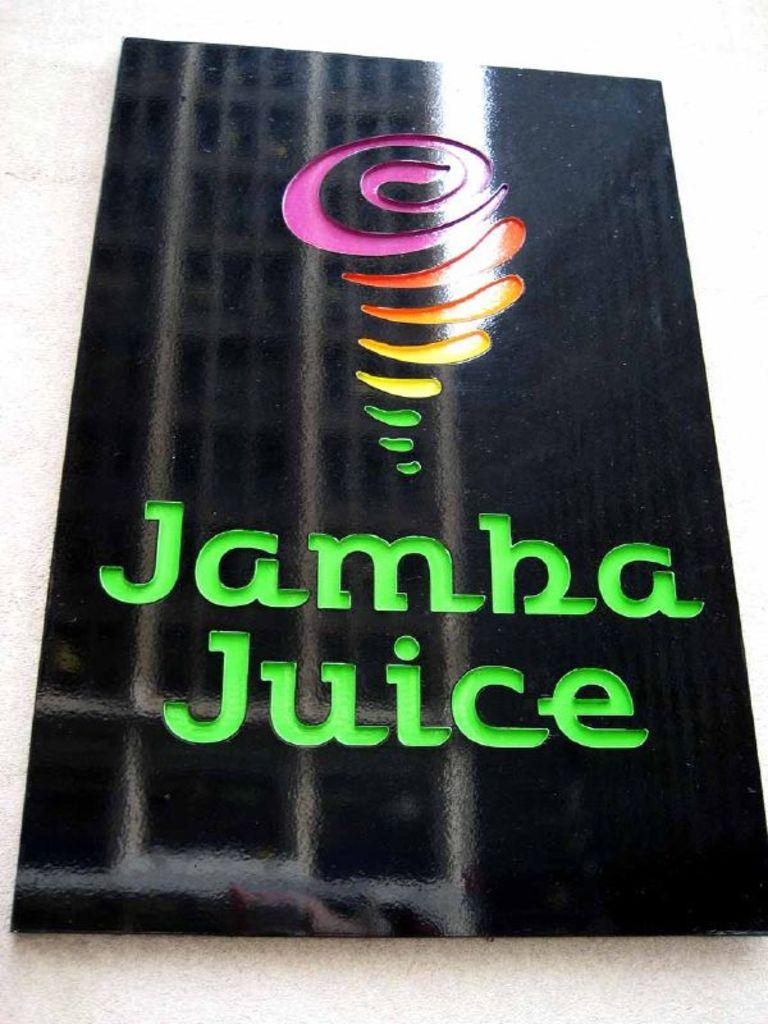Provide a one-sentence caption for the provided image. A sign for Jamba Juice hanging on the wall. 